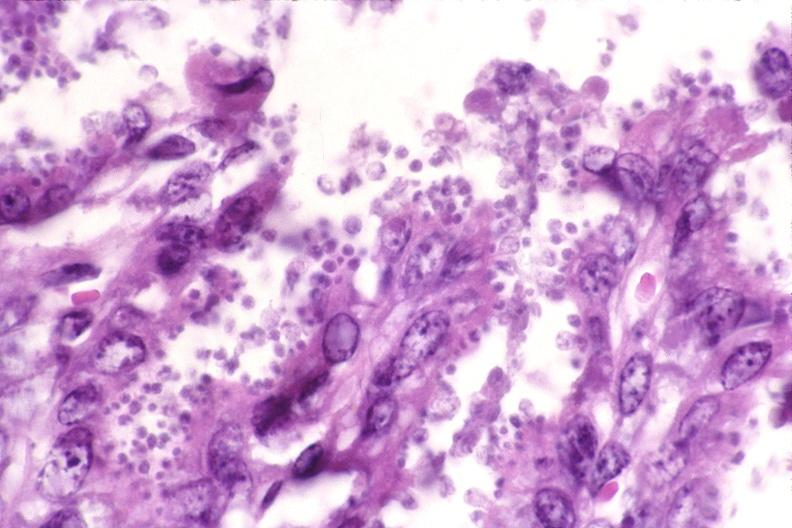does adrenal of premature 30 week gestation gram infant lesion show colon, cryptosporidia?
Answer the question using a single word or phrase. No 